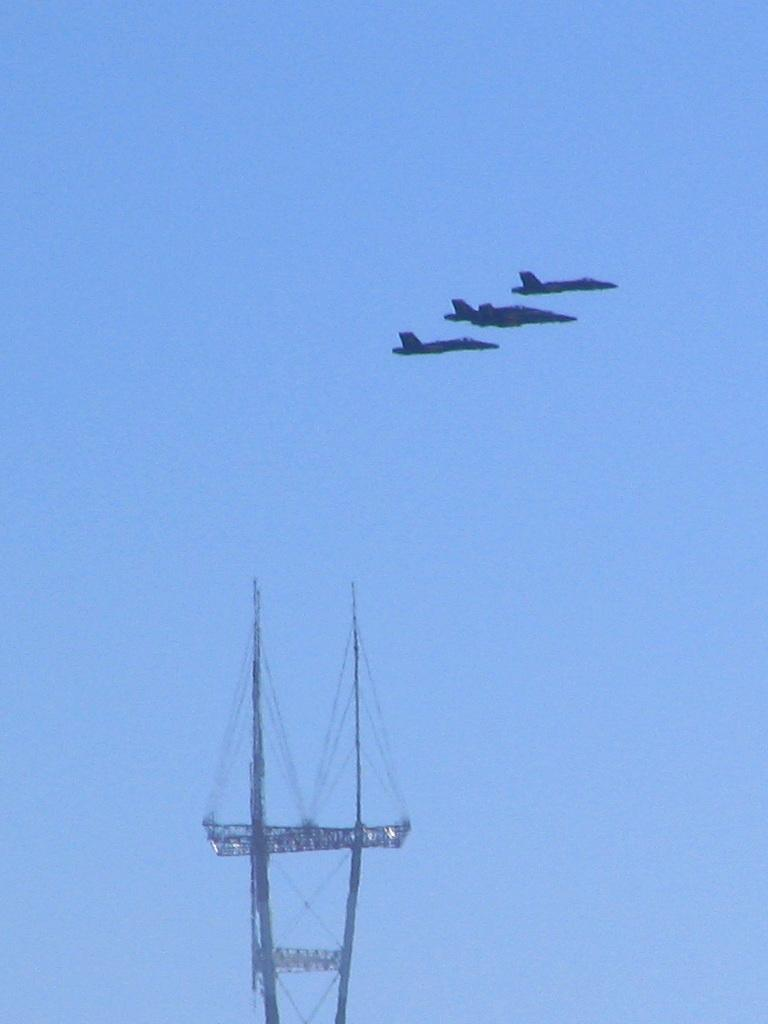How many planes can be seen in the image? There are three planes in the image. What are the planes doing in the image? The planes are flying in the sky. Can you describe the object below the planes? Unfortunately, the provided facts do not give any information about the object below the planes. What type of flowers can be seen growing near the planes in the image? There are no flowers present in the image; it only features three planes flying in the sky. How does the bee interact with the planes in the image? There is no bee present in the image, so it cannot interact with the planes. 